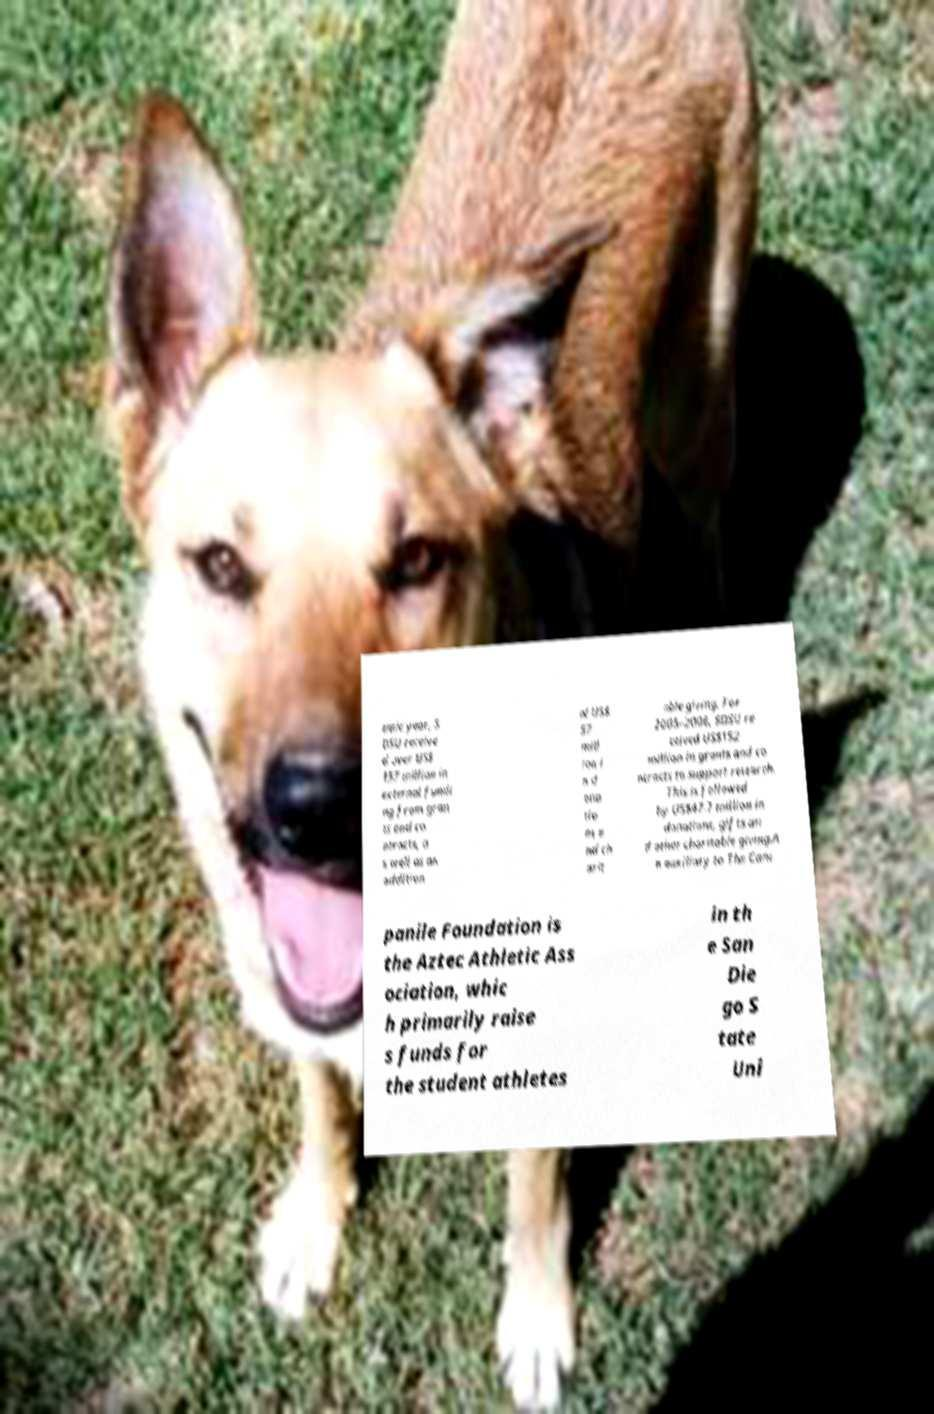Can you accurately transcribe the text from the provided image for me? emic year, S DSU receive d over US$ 157 million in external fundi ng from gran ts and co ntracts, a s well as an addition al US$ 57 mill ion i n d ona tio ns a nd ch arit able giving. For 2005–2006, SDSU re ceived US$152 million in grants and co ntracts to support research. This is followed by US$47.7 million in donations, gifts an d other charitable giving.A n auxiliary to The Cam panile Foundation is the Aztec Athletic Ass ociation, whic h primarily raise s funds for the student athletes in th e San Die go S tate Uni 